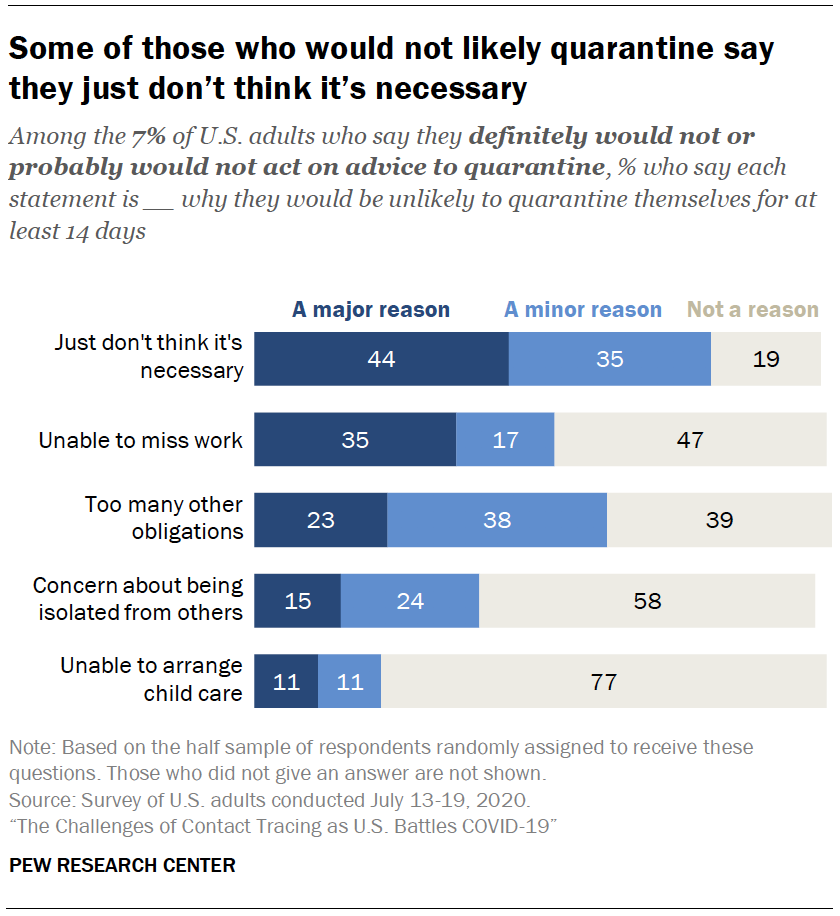Outline some significant characteristics in this image. The color of navy blue is a major reason for its popularity. Unable to arrange child care is a minor reason and a major reason for being unable to participate in the labor force in the United States. 